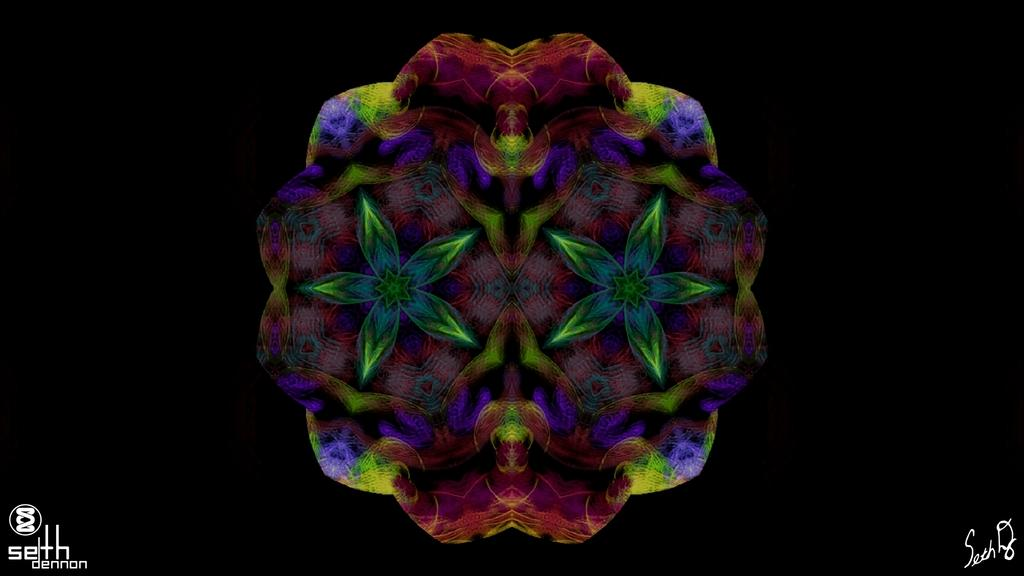What is the main subject of the image? There is a colorful object in the image. Can you describe the appearance of the object? The object has designs on it. What color is the background of the image? The background of the image is black. What type of library can be seen in the image? There is no library present in the image; it features a colorful object with designs on it against a black background. What subject is being taught in the image? There is no teaching or educational activity depicted in the image. 